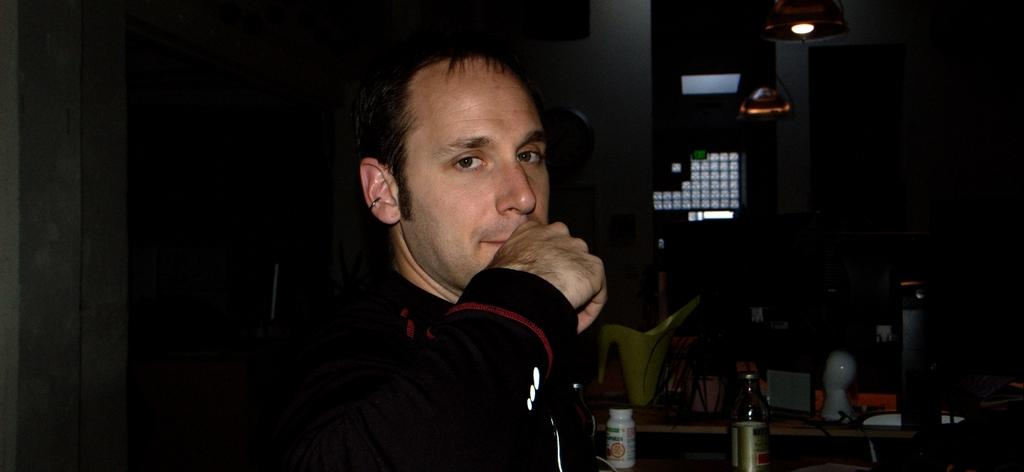What is the main subject in the center of the image? There is a person wearing a jacket in the center of the image. What can be seen in the background of the image? There is a table and a wall in the background of the image. How many objects are on the table? There are many objects on the table. What historical event is being commemorated by the wall in the image? There is no indication of a historical event or commemoration in the image; the wall is simply a part of the background. 